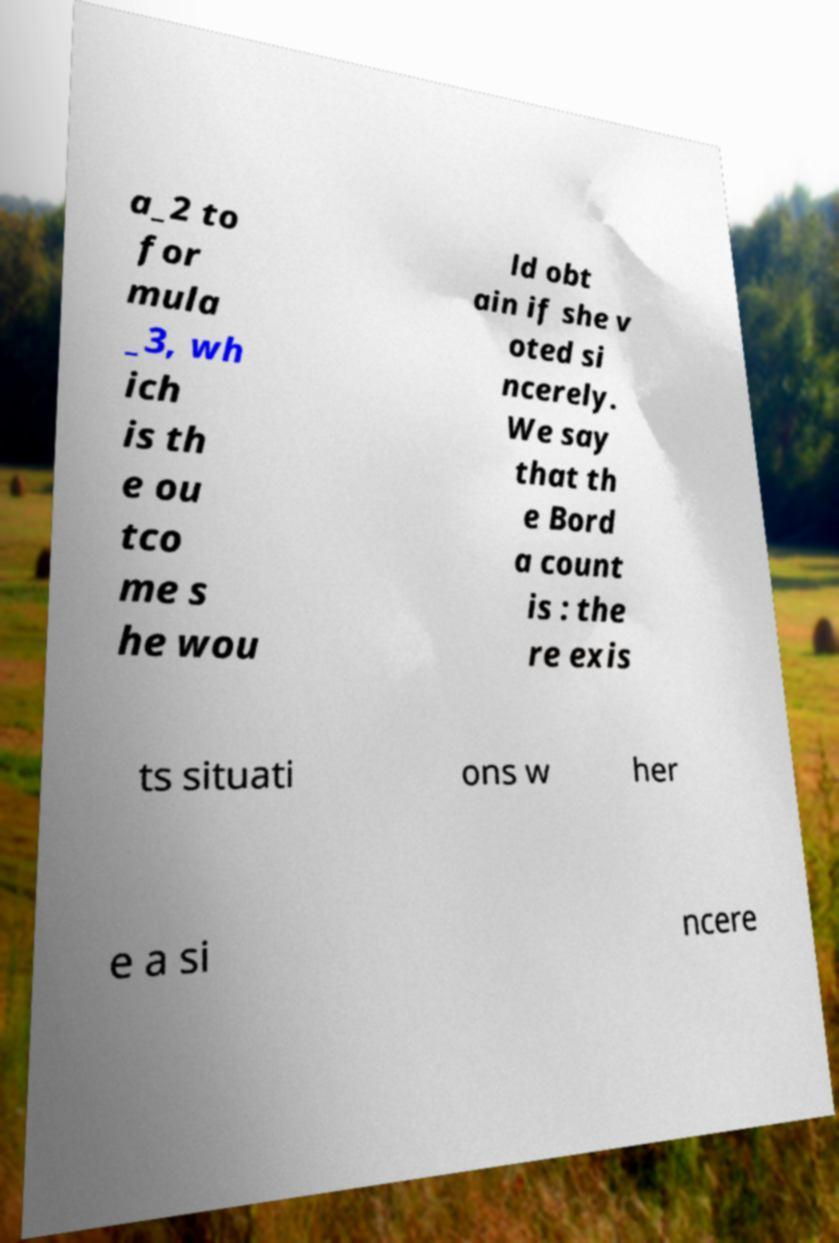What messages or text are displayed in this image? I need them in a readable, typed format. a_2 to for mula _3, wh ich is th e ou tco me s he wou ld obt ain if she v oted si ncerely. We say that th e Bord a count is : the re exis ts situati ons w her e a si ncere 